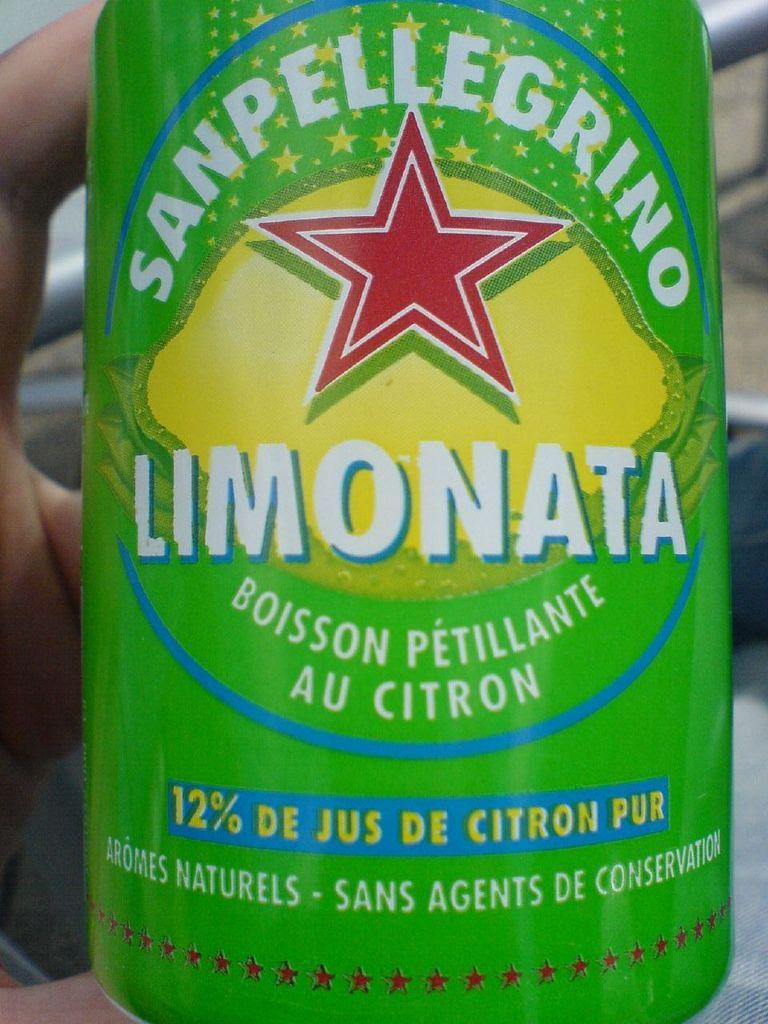<image>
Share a concise interpretation of the image provided. A green can of Sanpellegrino labeled as Limonata flavored. 